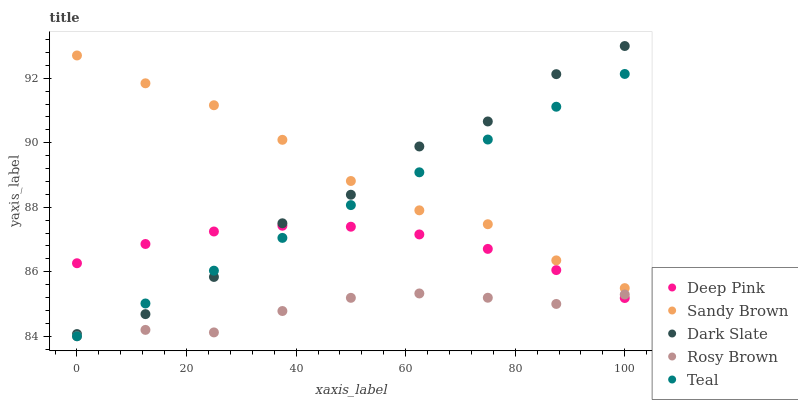Does Rosy Brown have the minimum area under the curve?
Answer yes or no. Yes. Does Sandy Brown have the maximum area under the curve?
Answer yes or no. Yes. Does Deep Pink have the minimum area under the curve?
Answer yes or no. No. Does Deep Pink have the maximum area under the curve?
Answer yes or no. No. Is Teal the smoothest?
Answer yes or no. Yes. Is Dark Slate the roughest?
Answer yes or no. Yes. Is Rosy Brown the smoothest?
Answer yes or no. No. Is Rosy Brown the roughest?
Answer yes or no. No. Does Rosy Brown have the lowest value?
Answer yes or no. Yes. Does Deep Pink have the lowest value?
Answer yes or no. No. Does Dark Slate have the highest value?
Answer yes or no. Yes. Does Deep Pink have the highest value?
Answer yes or no. No. Is Deep Pink less than Sandy Brown?
Answer yes or no. Yes. Is Dark Slate greater than Rosy Brown?
Answer yes or no. Yes. Does Teal intersect Sandy Brown?
Answer yes or no. Yes. Is Teal less than Sandy Brown?
Answer yes or no. No. Is Teal greater than Sandy Brown?
Answer yes or no. No. Does Deep Pink intersect Sandy Brown?
Answer yes or no. No. 